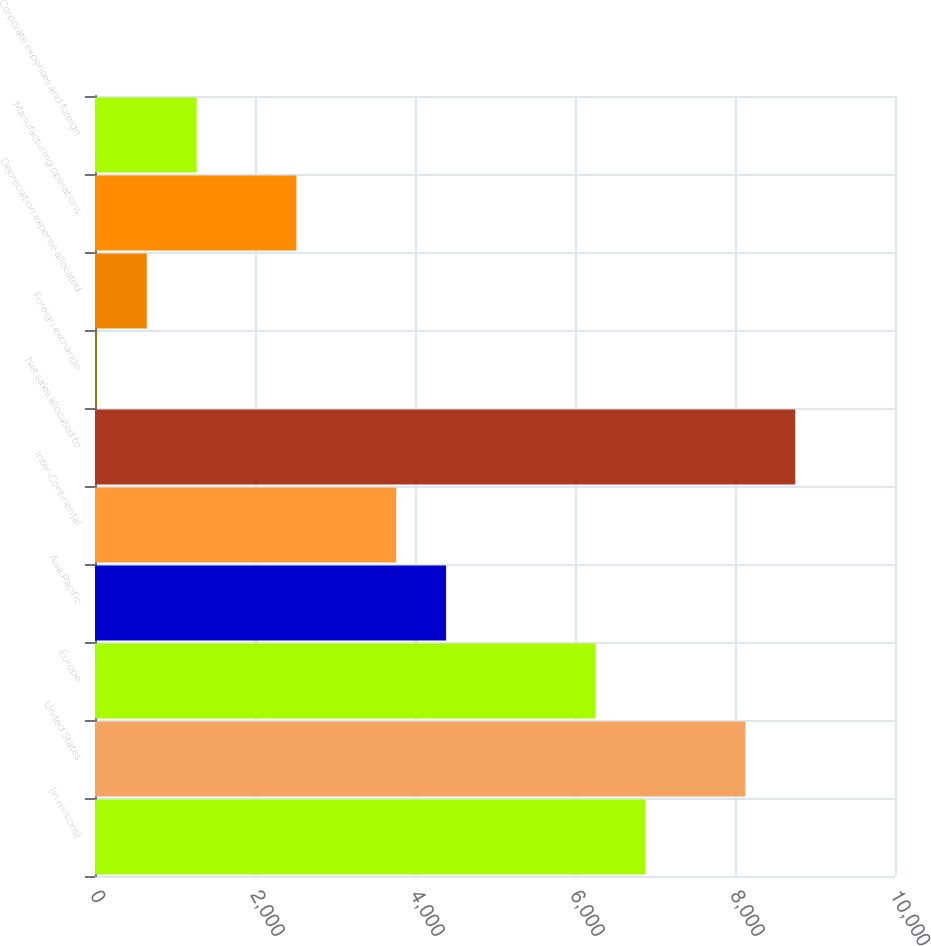<chart> <loc_0><loc_0><loc_500><loc_500><bar_chart><fcel>(in millions)<fcel>United States<fcel>Europe<fcel>Asia Pacific<fcel>Inter-Continental<fcel>Net sales allocated to<fcel>Foreign exchange<fcel>Depreciation expense allocated<fcel>Manufacturing operations<fcel>Corporate expenses and foreign<nl><fcel>6882.5<fcel>8129.5<fcel>6259<fcel>4388.5<fcel>3765<fcel>8753<fcel>24<fcel>647.5<fcel>2518<fcel>1271<nl></chart> 